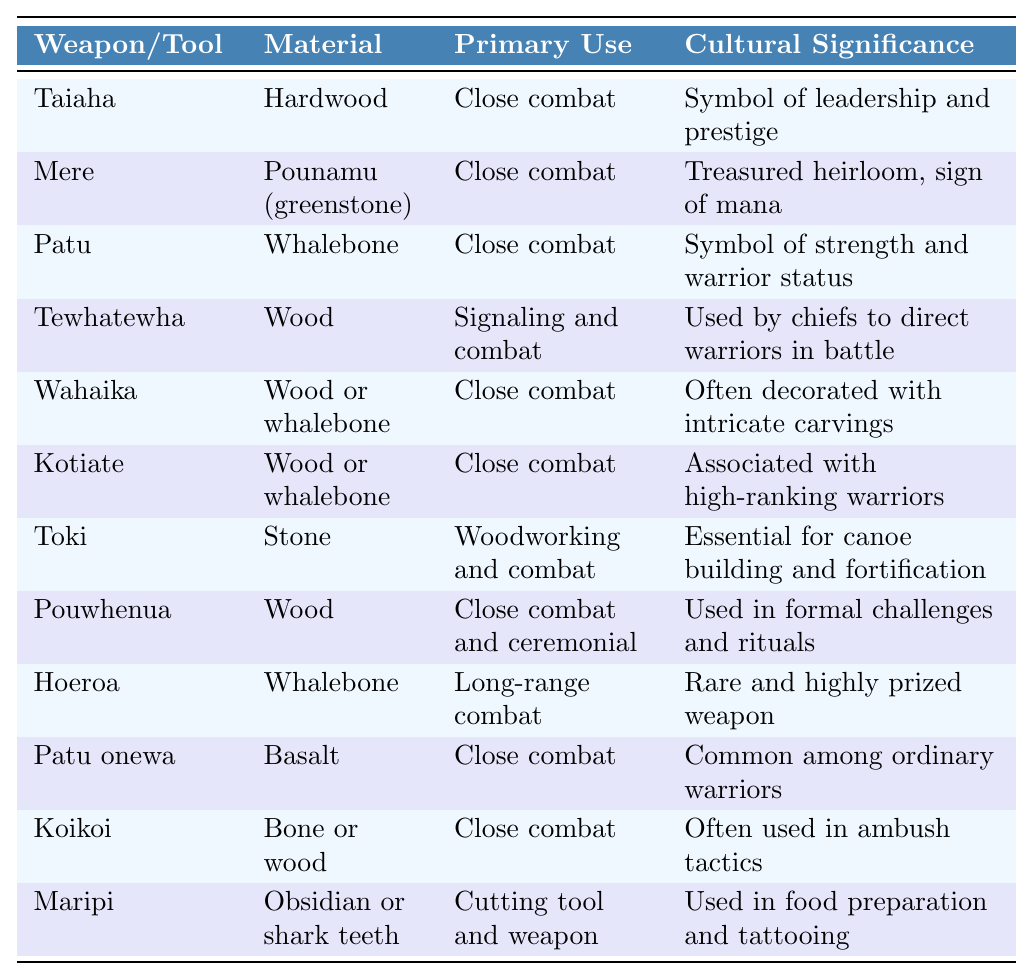What is the primary use of the Taiaha? The table clearly states that the Taiaha is primarily used for close combat.
Answer: Close combat Which weapon/tool is made of Pounamu? By looking at the table, it is evident that the Mere is made of Pounamu (greenstone).
Answer: Mere How many tools are primarily used for close combat? The table lists 7 tools that are specified for close combat. Counting them gives us the total: Taiaha, Mere, Patu, Wahaika, Kotiate, Patu onewa, and Koikoi.
Answer: 7 Is the Toki associated with high-ranking warriors? The table indicates that the Toki is essential for woodworking and combat but does not associate it with high-ranking warriors. Therefore, the statement is false.
Answer: No Which weapon/tool has cultural significance as a sign of mana? According to the table, the Mere is described as a treasured heirloom and a sign of mana.
Answer: Mere What material is used to make the Hoeroa? The table provides that the Hoeroa is made from whalebone.
Answer: Whalebone Which weapon/tool is used by chiefs to direct warriors in battle? The table explicitly states that the Tewhatewha is used by chiefs for this purpose.
Answer: Tewhatewha How many tools are made from whalebone? The table shows that there are 4 tools made from whalebone: Patu, Wahaika, Kotiate, and Hoeroa.
Answer: 4 Which weapon/tool is described as rare and highly prized? The entry for Hoeroa in the table describes it as a rare and highly prized weapon.
Answer: Hoeroa Are the materials used in the weapon/tools varied? The table lists several materials including hardwood, whalebone, pounamu, and stone among others. Therefore, it confirms that the materials are indeed varied.
Answer: Yes What is the cultural significance of the Patu? The table indicates that the Patu symbolizes strength and warrior status.
Answer: Strength and warrior status Which tools are identified as being used for signaling? From the table, the Tewhatewha is mentioned as being used for signaling in addition to combat.
Answer: Tewhatewha 